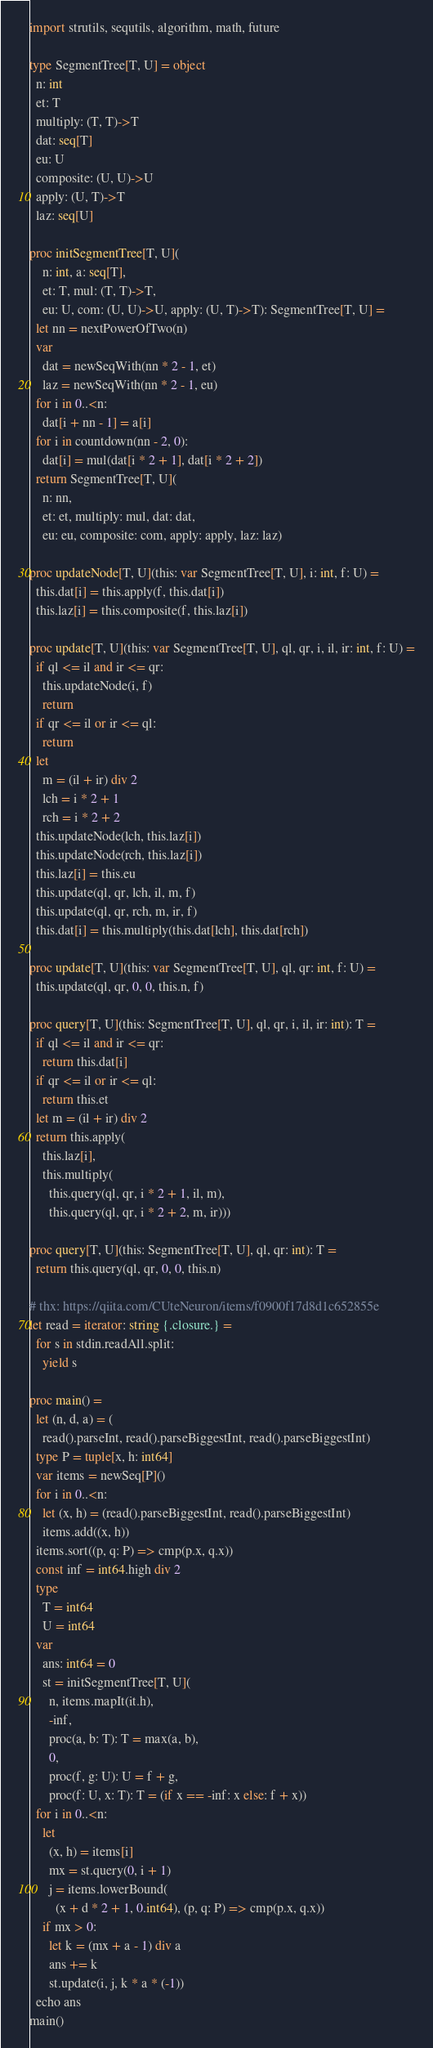Convert code to text. <code><loc_0><loc_0><loc_500><loc_500><_Nim_>import strutils, sequtils, algorithm, math, future

type SegmentTree[T, U] = object
  n: int
  et: T
  multiply: (T, T)->T
  dat: seq[T]
  eu: U
  composite: (U, U)->U
  apply: (U, T)->T
  laz: seq[U]

proc initSegmentTree[T, U](
    n: int, a: seq[T],
    et: T, mul: (T, T)->T,
    eu: U, com: (U, U)->U, apply: (U, T)->T): SegmentTree[T, U] =
  let nn = nextPowerOfTwo(n)
  var
    dat = newSeqWith(nn * 2 - 1, et)
    laz = newSeqWith(nn * 2 - 1, eu)
  for i in 0..<n:
    dat[i + nn - 1] = a[i]
  for i in countdown(nn - 2, 0):
    dat[i] = mul(dat[i * 2 + 1], dat[i * 2 + 2])
  return SegmentTree[T, U](
    n: nn,
    et: et, multiply: mul, dat: dat,
    eu: eu, composite: com, apply: apply, laz: laz)

proc updateNode[T, U](this: var SegmentTree[T, U], i: int, f: U) =
  this.dat[i] = this.apply(f, this.dat[i])
  this.laz[i] = this.composite(f, this.laz[i])

proc update[T, U](this: var SegmentTree[T, U], ql, qr, i, il, ir: int, f: U) =
  if ql <= il and ir <= qr:
    this.updateNode(i, f)
    return
  if qr <= il or ir <= ql:
    return
  let
    m = (il + ir) div 2
    lch = i * 2 + 1
    rch = i * 2 + 2
  this.updateNode(lch, this.laz[i])
  this.updateNode(rch, this.laz[i])
  this.laz[i] = this.eu
  this.update(ql, qr, lch, il, m, f)
  this.update(ql, qr, rch, m, ir, f)
  this.dat[i] = this.multiply(this.dat[lch], this.dat[rch])

proc update[T, U](this: var SegmentTree[T, U], ql, qr: int, f: U) =
  this.update(ql, qr, 0, 0, this.n, f)

proc query[T, U](this: SegmentTree[T, U], ql, qr, i, il, ir: int): T =
  if ql <= il and ir <= qr:
    return this.dat[i]
  if qr <= il or ir <= ql:
    return this.et
  let m = (il + ir) div 2
  return this.apply(
    this.laz[i],
    this.multiply(
      this.query(ql, qr, i * 2 + 1, il, m),
      this.query(ql, qr, i * 2 + 2, m, ir)))

proc query[T, U](this: SegmentTree[T, U], ql, qr: int): T =
  return this.query(ql, qr, 0, 0, this.n)

# thx: https://qiita.com/CUteNeuron/items/f0900f17d8d1c652855e
let read = iterator: string {.closure.} =
  for s in stdin.readAll.split:
    yield s

proc main() =
  let (n, d, a) = (
    read().parseInt, read().parseBiggestInt, read().parseBiggestInt)
  type P = tuple[x, h: int64]
  var items = newSeq[P]()
  for i in 0..<n:
    let (x, h) = (read().parseBiggestInt, read().parseBiggestInt)
    items.add((x, h))
  items.sort((p, q: P) => cmp(p.x, q.x))
  const inf = int64.high div 2
  type
    T = int64
    U = int64
  var
    ans: int64 = 0
    st = initSegmentTree[T, U](
      n, items.mapIt(it.h),
      -inf,
      proc(a, b: T): T = max(a, b),
      0,
      proc(f, g: U): U = f + g,
      proc(f: U, x: T): T = (if x == -inf: x else: f + x))
  for i in 0..<n:
    let
      (x, h) = items[i]
      mx = st.query(0, i + 1)
      j = items.lowerBound(
        (x + d * 2 + 1, 0.int64), (p, q: P) => cmp(p.x, q.x))
    if mx > 0:
      let k = (mx + a - 1) div a
      ans += k
      st.update(i, j, k * a * (-1))
  echo ans
main()
</code> 